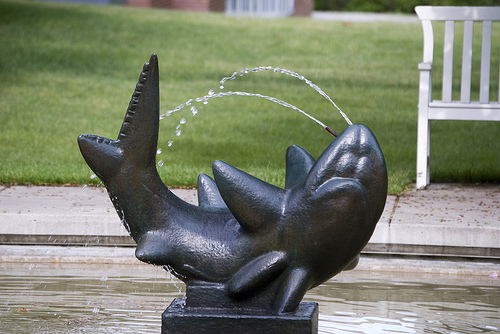<image>
Is the dolphins above the water? Yes. The dolphins is positioned above the water in the vertical space, higher up in the scene. 